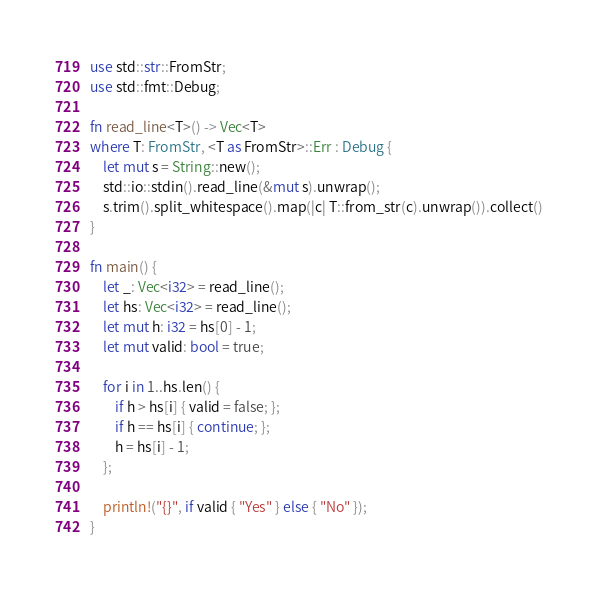Convert code to text. <code><loc_0><loc_0><loc_500><loc_500><_Rust_>use std::str::FromStr;
use std::fmt::Debug;

fn read_line<T>() -> Vec<T>
where T: FromStr, <T as FromStr>::Err : Debug {
    let mut s = String::new();
    std::io::stdin().read_line(&mut s).unwrap();
    s.trim().split_whitespace().map(|c| T::from_str(c).unwrap()).collect()
}

fn main() {
    let _: Vec<i32> = read_line();
    let hs: Vec<i32> = read_line();
    let mut h: i32 = hs[0] - 1;
    let mut valid: bool = true;

    for i in 1..hs.len() {
        if h > hs[i] { valid = false; };
        if h == hs[i] { continue; };
        h = hs[i] - 1;
    };

    println!("{}", if valid { "Yes" } else { "No" });
}</code> 